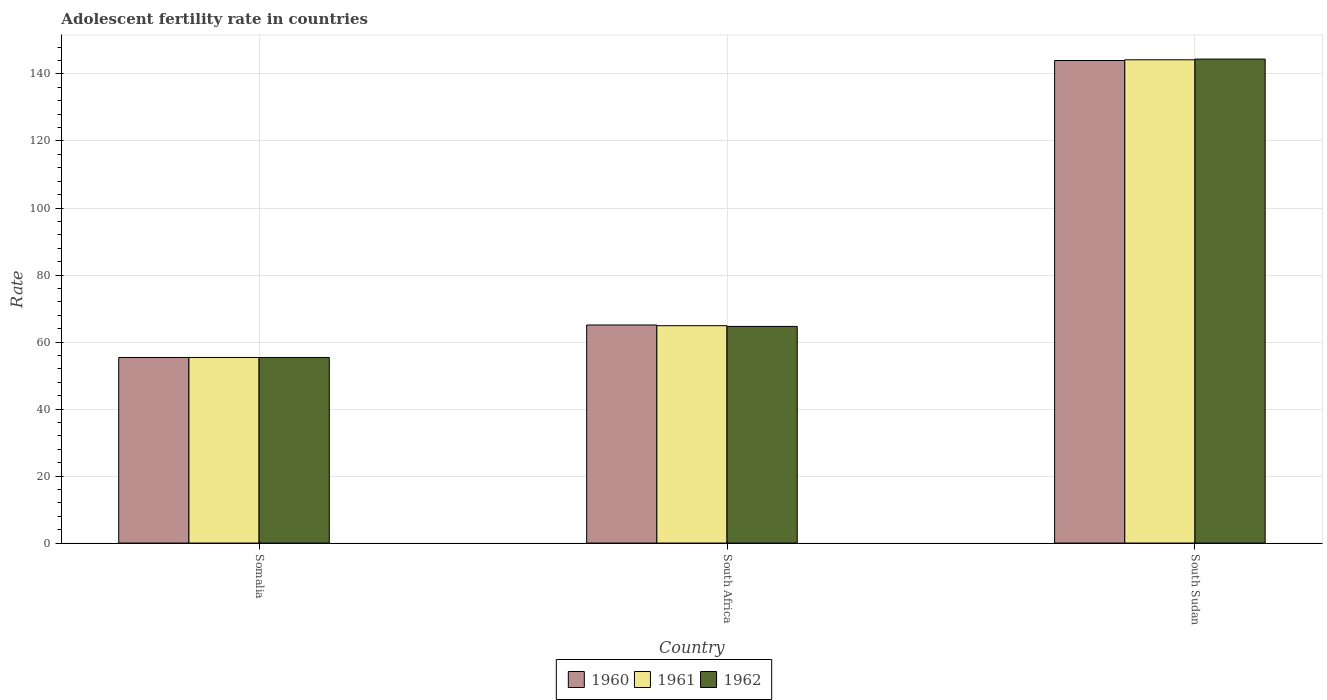How many groups of bars are there?
Your answer should be compact. 3. Are the number of bars per tick equal to the number of legend labels?
Keep it short and to the point. Yes. Are the number of bars on each tick of the X-axis equal?
Your response must be concise. Yes. How many bars are there on the 2nd tick from the left?
Keep it short and to the point. 3. What is the label of the 3rd group of bars from the left?
Make the answer very short. South Sudan. In how many cases, is the number of bars for a given country not equal to the number of legend labels?
Your answer should be very brief. 0. What is the adolescent fertility rate in 1961 in South Africa?
Give a very brief answer. 64.87. Across all countries, what is the maximum adolescent fertility rate in 1961?
Your response must be concise. 144.24. Across all countries, what is the minimum adolescent fertility rate in 1961?
Your answer should be compact. 55.39. In which country was the adolescent fertility rate in 1961 maximum?
Your answer should be compact. South Sudan. In which country was the adolescent fertility rate in 1960 minimum?
Make the answer very short. Somalia. What is the total adolescent fertility rate in 1960 in the graph?
Make the answer very short. 264.5. What is the difference between the adolescent fertility rate in 1961 in South Africa and that in South Sudan?
Provide a short and direct response. -79.36. What is the difference between the adolescent fertility rate in 1962 in South Sudan and the adolescent fertility rate in 1960 in Somalia?
Keep it short and to the point. 89.06. What is the average adolescent fertility rate in 1961 per country?
Offer a terse response. 88.17. What is the difference between the adolescent fertility rate of/in 1962 and adolescent fertility rate of/in 1961 in Somalia?
Offer a very short reply. 0. What is the ratio of the adolescent fertility rate in 1962 in Somalia to that in South Sudan?
Make the answer very short. 0.38. Is the adolescent fertility rate in 1961 in Somalia less than that in South Sudan?
Make the answer very short. Yes. Is the difference between the adolescent fertility rate in 1962 in Somalia and South Sudan greater than the difference between the adolescent fertility rate in 1961 in Somalia and South Sudan?
Offer a terse response. No. What is the difference between the highest and the second highest adolescent fertility rate in 1961?
Make the answer very short. 79.36. What is the difference between the highest and the lowest adolescent fertility rate in 1960?
Provide a short and direct response. 88.63. In how many countries, is the adolescent fertility rate in 1962 greater than the average adolescent fertility rate in 1962 taken over all countries?
Make the answer very short. 1. What does the 1st bar from the right in South Africa represents?
Provide a short and direct response. 1962. How many bars are there?
Give a very brief answer. 9. What is the difference between two consecutive major ticks on the Y-axis?
Your answer should be very brief. 20. Are the values on the major ticks of Y-axis written in scientific E-notation?
Provide a short and direct response. No. Does the graph contain grids?
Provide a succinct answer. Yes. Where does the legend appear in the graph?
Offer a very short reply. Bottom center. How many legend labels are there?
Provide a short and direct response. 3. What is the title of the graph?
Provide a succinct answer. Adolescent fertility rate in countries. What is the label or title of the Y-axis?
Provide a succinct answer. Rate. What is the Rate in 1960 in Somalia?
Ensure brevity in your answer.  55.39. What is the Rate in 1961 in Somalia?
Your answer should be very brief. 55.39. What is the Rate of 1962 in Somalia?
Your answer should be compact. 55.39. What is the Rate of 1960 in South Africa?
Give a very brief answer. 65.08. What is the Rate in 1961 in South Africa?
Give a very brief answer. 64.87. What is the Rate in 1962 in South Africa?
Provide a short and direct response. 64.66. What is the Rate of 1960 in South Sudan?
Your answer should be compact. 144.02. What is the Rate of 1961 in South Sudan?
Keep it short and to the point. 144.24. What is the Rate of 1962 in South Sudan?
Your answer should be compact. 144.45. Across all countries, what is the maximum Rate of 1960?
Your response must be concise. 144.02. Across all countries, what is the maximum Rate in 1961?
Your response must be concise. 144.24. Across all countries, what is the maximum Rate in 1962?
Your response must be concise. 144.45. Across all countries, what is the minimum Rate in 1960?
Provide a succinct answer. 55.39. Across all countries, what is the minimum Rate in 1961?
Offer a very short reply. 55.39. Across all countries, what is the minimum Rate in 1962?
Make the answer very short. 55.39. What is the total Rate of 1960 in the graph?
Provide a succinct answer. 264.5. What is the total Rate in 1961 in the graph?
Make the answer very short. 264.5. What is the total Rate of 1962 in the graph?
Provide a short and direct response. 264.5. What is the difference between the Rate in 1960 in Somalia and that in South Africa?
Offer a very short reply. -9.7. What is the difference between the Rate in 1961 in Somalia and that in South Africa?
Make the answer very short. -9.48. What is the difference between the Rate of 1962 in Somalia and that in South Africa?
Offer a very short reply. -9.27. What is the difference between the Rate in 1960 in Somalia and that in South Sudan?
Your answer should be very brief. -88.63. What is the difference between the Rate of 1961 in Somalia and that in South Sudan?
Ensure brevity in your answer.  -88.85. What is the difference between the Rate of 1962 in Somalia and that in South Sudan?
Give a very brief answer. -89.06. What is the difference between the Rate of 1960 in South Africa and that in South Sudan?
Offer a very short reply. -78.94. What is the difference between the Rate of 1961 in South Africa and that in South Sudan?
Make the answer very short. -79.36. What is the difference between the Rate in 1962 in South Africa and that in South Sudan?
Your answer should be compact. -79.79. What is the difference between the Rate of 1960 in Somalia and the Rate of 1961 in South Africa?
Your response must be concise. -9.48. What is the difference between the Rate in 1960 in Somalia and the Rate in 1962 in South Africa?
Provide a succinct answer. -9.27. What is the difference between the Rate of 1961 in Somalia and the Rate of 1962 in South Africa?
Make the answer very short. -9.27. What is the difference between the Rate in 1960 in Somalia and the Rate in 1961 in South Sudan?
Offer a terse response. -88.85. What is the difference between the Rate of 1960 in Somalia and the Rate of 1962 in South Sudan?
Ensure brevity in your answer.  -89.06. What is the difference between the Rate of 1961 in Somalia and the Rate of 1962 in South Sudan?
Keep it short and to the point. -89.06. What is the difference between the Rate of 1960 in South Africa and the Rate of 1961 in South Sudan?
Give a very brief answer. -79.15. What is the difference between the Rate of 1960 in South Africa and the Rate of 1962 in South Sudan?
Provide a succinct answer. -79.37. What is the difference between the Rate of 1961 in South Africa and the Rate of 1962 in South Sudan?
Provide a succinct answer. -79.58. What is the average Rate in 1960 per country?
Provide a succinct answer. 88.17. What is the average Rate in 1961 per country?
Offer a very short reply. 88.17. What is the average Rate in 1962 per country?
Offer a terse response. 88.17. What is the difference between the Rate in 1960 and Rate in 1961 in Somalia?
Keep it short and to the point. 0. What is the difference between the Rate of 1960 and Rate of 1962 in Somalia?
Your answer should be very brief. 0. What is the difference between the Rate in 1960 and Rate in 1961 in South Africa?
Offer a very short reply. 0.21. What is the difference between the Rate of 1960 and Rate of 1962 in South Africa?
Make the answer very short. 0.42. What is the difference between the Rate of 1961 and Rate of 1962 in South Africa?
Your response must be concise. 0.21. What is the difference between the Rate in 1960 and Rate in 1961 in South Sudan?
Your response must be concise. -0.21. What is the difference between the Rate of 1960 and Rate of 1962 in South Sudan?
Provide a short and direct response. -0.43. What is the difference between the Rate of 1961 and Rate of 1962 in South Sudan?
Provide a succinct answer. -0.21. What is the ratio of the Rate in 1960 in Somalia to that in South Africa?
Keep it short and to the point. 0.85. What is the ratio of the Rate in 1961 in Somalia to that in South Africa?
Offer a terse response. 0.85. What is the ratio of the Rate in 1962 in Somalia to that in South Africa?
Offer a very short reply. 0.86. What is the ratio of the Rate of 1960 in Somalia to that in South Sudan?
Make the answer very short. 0.38. What is the ratio of the Rate in 1961 in Somalia to that in South Sudan?
Ensure brevity in your answer.  0.38. What is the ratio of the Rate of 1962 in Somalia to that in South Sudan?
Give a very brief answer. 0.38. What is the ratio of the Rate in 1960 in South Africa to that in South Sudan?
Your answer should be very brief. 0.45. What is the ratio of the Rate in 1961 in South Africa to that in South Sudan?
Offer a terse response. 0.45. What is the ratio of the Rate in 1962 in South Africa to that in South Sudan?
Your answer should be very brief. 0.45. What is the difference between the highest and the second highest Rate of 1960?
Provide a succinct answer. 78.94. What is the difference between the highest and the second highest Rate of 1961?
Ensure brevity in your answer.  79.36. What is the difference between the highest and the second highest Rate in 1962?
Your response must be concise. 79.79. What is the difference between the highest and the lowest Rate of 1960?
Ensure brevity in your answer.  88.63. What is the difference between the highest and the lowest Rate in 1961?
Give a very brief answer. 88.85. What is the difference between the highest and the lowest Rate in 1962?
Make the answer very short. 89.06. 